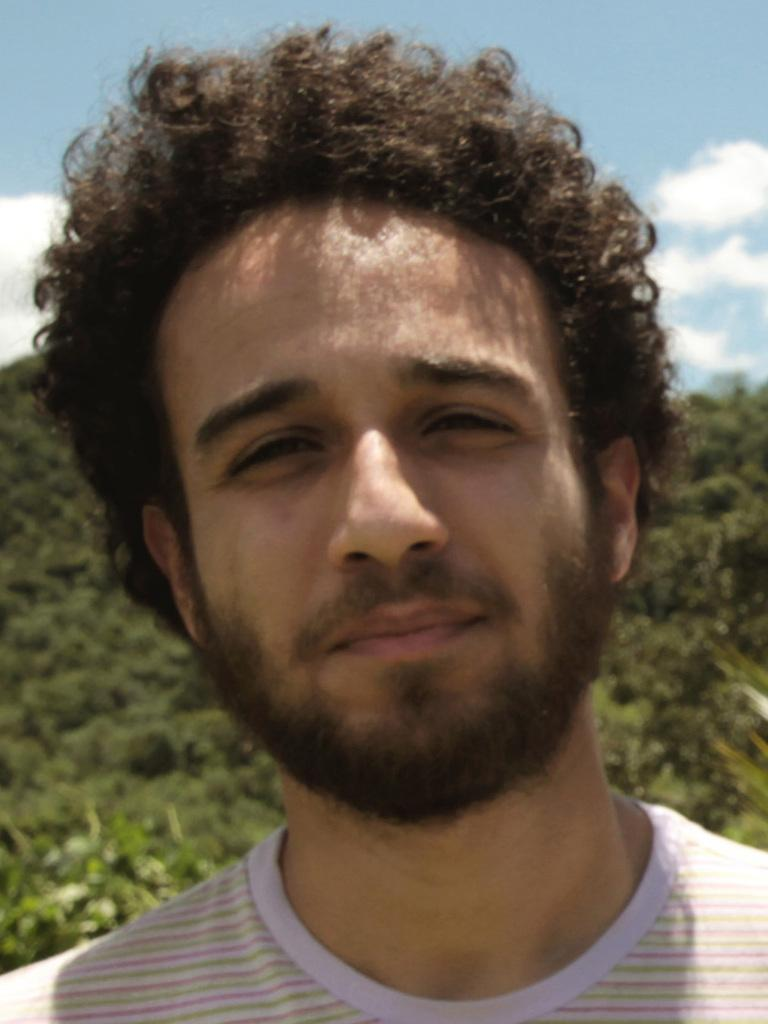What is the main subject of the image? There is a man in the image. What type of shirt is the man wearing? The man is wearing a round neck shirt. Can you describe the man's hair? The man has curly hair. What can be seen in the background of the image? There are trees behind the man, and the sky is visible in the background. How many sisters does the man have in the image? There is no information about the man's sisters in the image. Can you see any wings on the man in the image? There are no wings visible on the man in the image. 